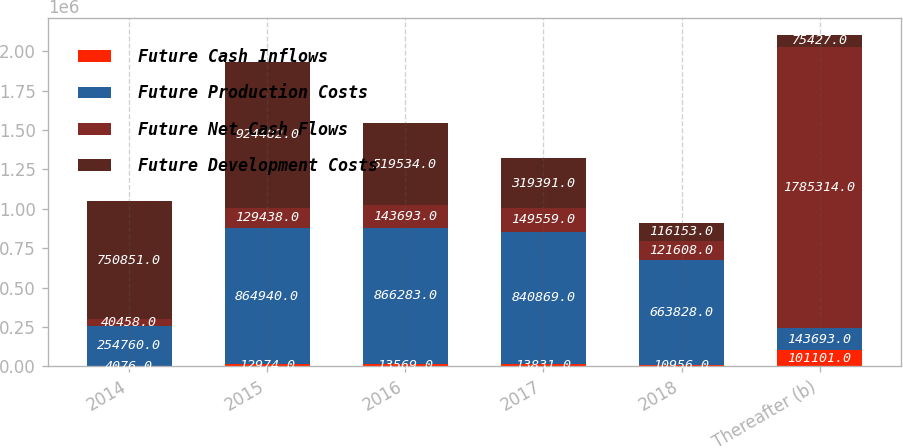Convert chart to OTSL. <chart><loc_0><loc_0><loc_500><loc_500><stacked_bar_chart><ecel><fcel>2014<fcel>2015<fcel>2016<fcel>2017<fcel>2018<fcel>Thereafter (b)<nl><fcel>Future Cash Inflows<fcel>4076<fcel>12974<fcel>13569<fcel>13831<fcel>10956<fcel>101101<nl><fcel>Future Production Costs<fcel>254760<fcel>864940<fcel>866283<fcel>840869<fcel>663828<fcel>143693<nl><fcel>Future Net Cash Flows<fcel>40458<fcel>129438<fcel>143693<fcel>149559<fcel>121608<fcel>1.78531e+06<nl><fcel>Future Development Costs<fcel>750851<fcel>924482<fcel>519534<fcel>319391<fcel>116153<fcel>75427<nl></chart> 